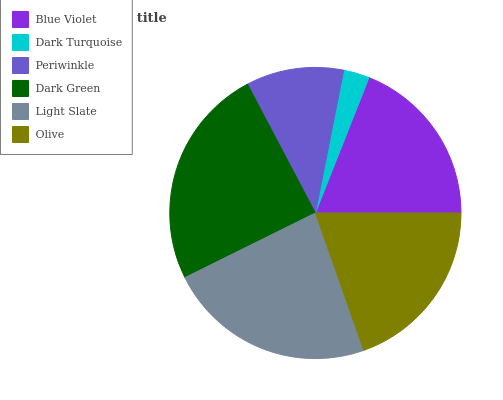Is Dark Turquoise the minimum?
Answer yes or no. Yes. Is Dark Green the maximum?
Answer yes or no. Yes. Is Periwinkle the minimum?
Answer yes or no. No. Is Periwinkle the maximum?
Answer yes or no. No. Is Periwinkle greater than Dark Turquoise?
Answer yes or no. Yes. Is Dark Turquoise less than Periwinkle?
Answer yes or no. Yes. Is Dark Turquoise greater than Periwinkle?
Answer yes or no. No. Is Periwinkle less than Dark Turquoise?
Answer yes or no. No. Is Olive the high median?
Answer yes or no. Yes. Is Blue Violet the low median?
Answer yes or no. Yes. Is Dark Turquoise the high median?
Answer yes or no. No. Is Dark Turquoise the low median?
Answer yes or no. No. 